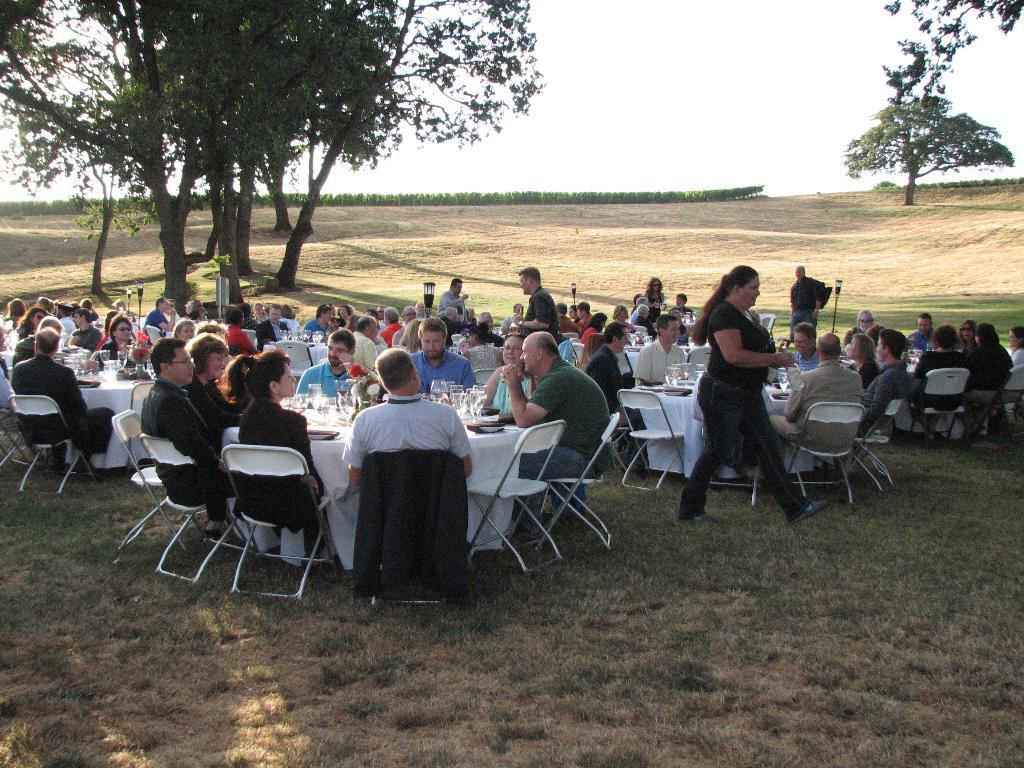What type of vegetation can be seen in the image? There are trees in the image. What part of the natural environment is visible in the image? The sky and grass are visible in the image. Can the ground be seen in the image? Yes, the ground is visible in the image. What are the people in the image doing? The people are sitting on chairs in the image}. What is on the table in the image? There is a table in the image with glasses and plates on it}. What type of slope can be seen in the image? There is no slope present in the image. How many knots are tied on the plates in the image? There are no knots on the plates in the image; they are used for serving food. What type of pie is being served on the table in the image? There is no pie present in the image; only glasses and plates are visible on the table. 